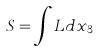Convert formula to latex. <formula><loc_0><loc_0><loc_500><loc_500>S = \int L d x _ { 3 }</formula> 